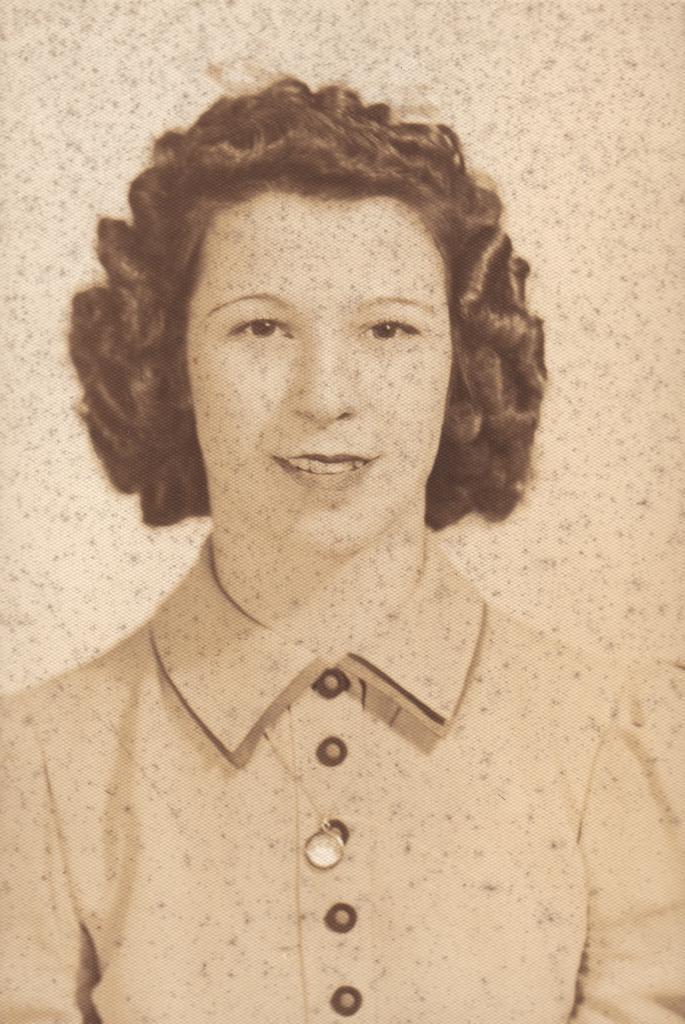Who is present in the image? There is a woman in the image. What can be seen behind the woman? The background of the image is cream-colored. What type of toy can be seen in the woman's hand in the image? There is no toy present in the woman's hand or in the image. 